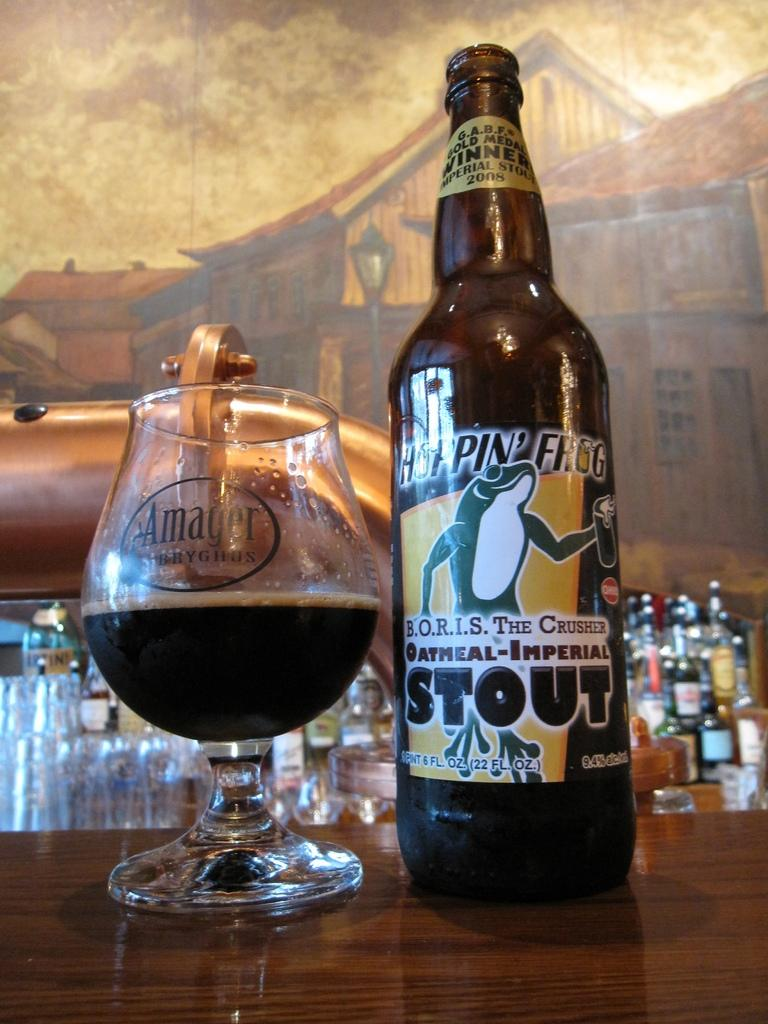<image>
Offer a succinct explanation of the picture presented. a bottle of beer that says 'hoppin' frog' on it 